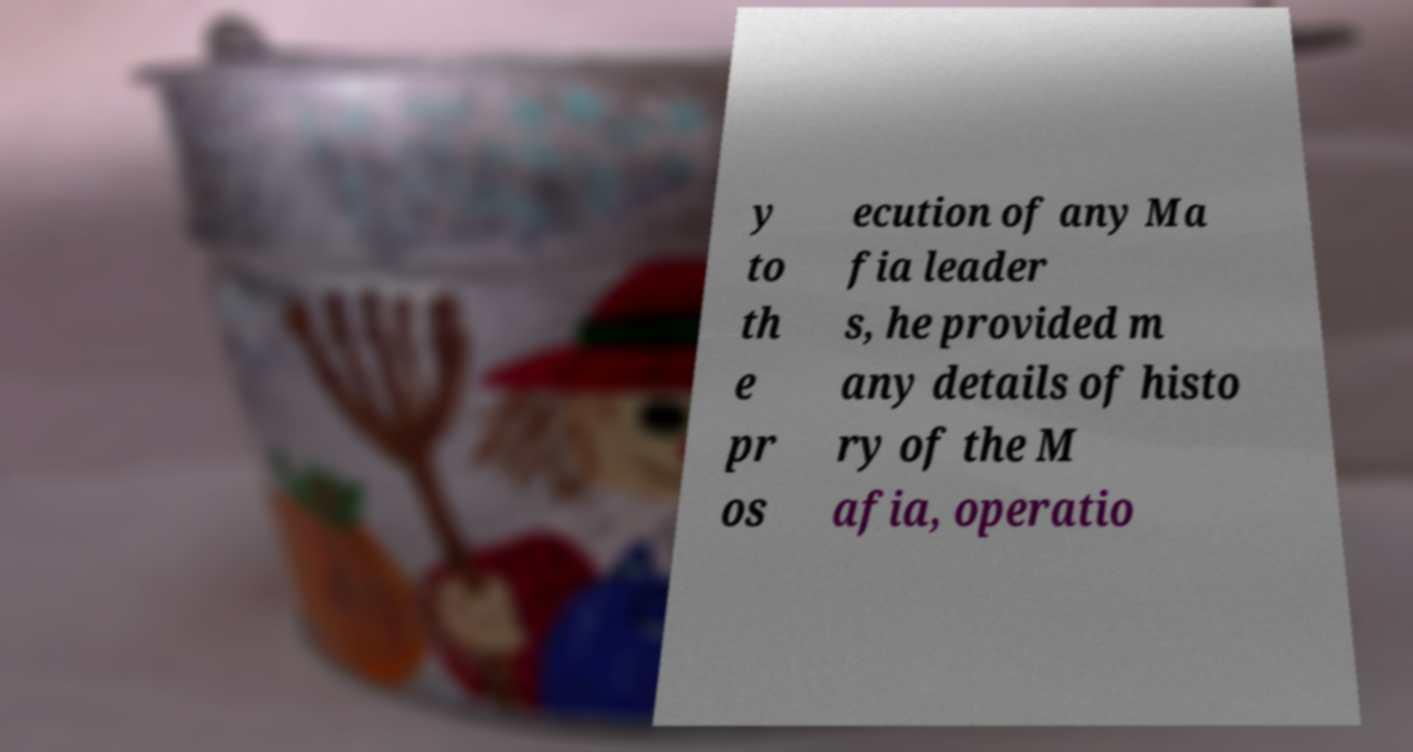Could you extract and type out the text from this image? y to th e pr os ecution of any Ma fia leader s, he provided m any details of histo ry of the M afia, operatio 